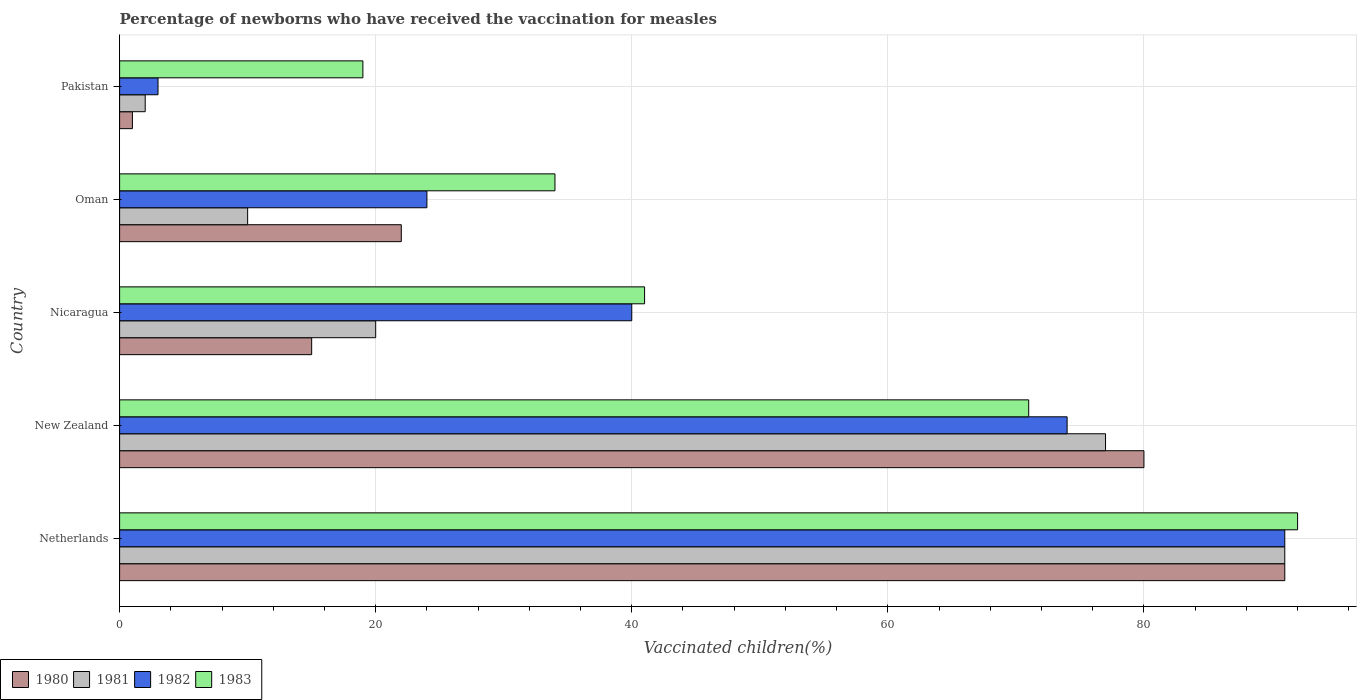How many different coloured bars are there?
Your answer should be very brief. 4. How many groups of bars are there?
Ensure brevity in your answer.  5. Are the number of bars per tick equal to the number of legend labels?
Offer a very short reply. Yes. Are the number of bars on each tick of the Y-axis equal?
Keep it short and to the point. Yes. What is the label of the 2nd group of bars from the top?
Keep it short and to the point. Oman. In how many cases, is the number of bars for a given country not equal to the number of legend labels?
Your answer should be very brief. 0. Across all countries, what is the maximum percentage of vaccinated children in 1981?
Your answer should be compact. 91. In which country was the percentage of vaccinated children in 1980 maximum?
Offer a terse response. Netherlands. In which country was the percentage of vaccinated children in 1980 minimum?
Make the answer very short. Pakistan. What is the total percentage of vaccinated children in 1983 in the graph?
Provide a succinct answer. 257. What is the difference between the percentage of vaccinated children in 1980 in Netherlands and the percentage of vaccinated children in 1983 in New Zealand?
Keep it short and to the point. 20. What is the average percentage of vaccinated children in 1983 per country?
Provide a short and direct response. 51.4. What is the difference between the percentage of vaccinated children in 1980 and percentage of vaccinated children in 1983 in Nicaragua?
Make the answer very short. -26. In how many countries, is the percentage of vaccinated children in 1982 greater than 36 %?
Provide a short and direct response. 3. What is the ratio of the percentage of vaccinated children in 1981 in Nicaragua to that in Oman?
Give a very brief answer. 2. Is the percentage of vaccinated children in 1980 in Oman less than that in Pakistan?
Provide a succinct answer. No. Is the difference between the percentage of vaccinated children in 1980 in Netherlands and Oman greater than the difference between the percentage of vaccinated children in 1983 in Netherlands and Oman?
Your answer should be very brief. Yes. What is the difference between the highest and the second highest percentage of vaccinated children in 1982?
Your answer should be very brief. 17. In how many countries, is the percentage of vaccinated children in 1983 greater than the average percentage of vaccinated children in 1983 taken over all countries?
Your answer should be very brief. 2. Is it the case that in every country, the sum of the percentage of vaccinated children in 1981 and percentage of vaccinated children in 1983 is greater than the sum of percentage of vaccinated children in 1980 and percentage of vaccinated children in 1982?
Your answer should be very brief. No. What does the 1st bar from the top in New Zealand represents?
Keep it short and to the point. 1983. What does the 4th bar from the bottom in New Zealand represents?
Your answer should be very brief. 1983. Is it the case that in every country, the sum of the percentage of vaccinated children in 1981 and percentage of vaccinated children in 1983 is greater than the percentage of vaccinated children in 1982?
Ensure brevity in your answer.  Yes. How many bars are there?
Ensure brevity in your answer.  20. Are all the bars in the graph horizontal?
Ensure brevity in your answer.  Yes. Does the graph contain grids?
Offer a very short reply. Yes. Where does the legend appear in the graph?
Keep it short and to the point. Bottom left. How are the legend labels stacked?
Your answer should be compact. Horizontal. What is the title of the graph?
Provide a succinct answer. Percentage of newborns who have received the vaccination for measles. Does "1981" appear as one of the legend labels in the graph?
Make the answer very short. Yes. What is the label or title of the X-axis?
Your response must be concise. Vaccinated children(%). What is the label or title of the Y-axis?
Provide a short and direct response. Country. What is the Vaccinated children(%) of 1980 in Netherlands?
Make the answer very short. 91. What is the Vaccinated children(%) in 1981 in Netherlands?
Give a very brief answer. 91. What is the Vaccinated children(%) in 1982 in Netherlands?
Provide a succinct answer. 91. What is the Vaccinated children(%) of 1983 in Netherlands?
Your response must be concise. 92. What is the Vaccinated children(%) of 1980 in New Zealand?
Offer a terse response. 80. What is the Vaccinated children(%) in 1982 in New Zealand?
Give a very brief answer. 74. What is the Vaccinated children(%) of 1980 in Nicaragua?
Your answer should be compact. 15. What is the Vaccinated children(%) of 1983 in Nicaragua?
Offer a very short reply. 41. What is the Vaccinated children(%) in 1980 in Oman?
Provide a succinct answer. 22. What is the Vaccinated children(%) in 1981 in Oman?
Ensure brevity in your answer.  10. Across all countries, what is the maximum Vaccinated children(%) of 1980?
Provide a short and direct response. 91. Across all countries, what is the maximum Vaccinated children(%) of 1981?
Your response must be concise. 91. Across all countries, what is the maximum Vaccinated children(%) in 1982?
Your answer should be very brief. 91. Across all countries, what is the maximum Vaccinated children(%) of 1983?
Make the answer very short. 92. Across all countries, what is the minimum Vaccinated children(%) in 1980?
Your response must be concise. 1. Across all countries, what is the minimum Vaccinated children(%) in 1982?
Offer a terse response. 3. What is the total Vaccinated children(%) of 1980 in the graph?
Provide a short and direct response. 209. What is the total Vaccinated children(%) of 1981 in the graph?
Ensure brevity in your answer.  200. What is the total Vaccinated children(%) of 1982 in the graph?
Provide a short and direct response. 232. What is the total Vaccinated children(%) of 1983 in the graph?
Your answer should be compact. 257. What is the difference between the Vaccinated children(%) in 1983 in Netherlands and that in New Zealand?
Keep it short and to the point. 21. What is the difference between the Vaccinated children(%) of 1980 in Netherlands and that in Nicaragua?
Your answer should be compact. 76. What is the difference between the Vaccinated children(%) of 1981 in Netherlands and that in Nicaragua?
Provide a succinct answer. 71. What is the difference between the Vaccinated children(%) of 1983 in Netherlands and that in Nicaragua?
Offer a terse response. 51. What is the difference between the Vaccinated children(%) of 1980 in Netherlands and that in Oman?
Offer a terse response. 69. What is the difference between the Vaccinated children(%) in 1980 in Netherlands and that in Pakistan?
Offer a terse response. 90. What is the difference between the Vaccinated children(%) in 1981 in Netherlands and that in Pakistan?
Offer a very short reply. 89. What is the difference between the Vaccinated children(%) in 1982 in Netherlands and that in Pakistan?
Ensure brevity in your answer.  88. What is the difference between the Vaccinated children(%) of 1983 in Netherlands and that in Pakistan?
Make the answer very short. 73. What is the difference between the Vaccinated children(%) in 1980 in New Zealand and that in Nicaragua?
Offer a very short reply. 65. What is the difference between the Vaccinated children(%) in 1981 in New Zealand and that in Nicaragua?
Ensure brevity in your answer.  57. What is the difference between the Vaccinated children(%) in 1983 in New Zealand and that in Nicaragua?
Your answer should be very brief. 30. What is the difference between the Vaccinated children(%) of 1980 in New Zealand and that in Pakistan?
Your response must be concise. 79. What is the difference between the Vaccinated children(%) of 1981 in New Zealand and that in Pakistan?
Ensure brevity in your answer.  75. What is the difference between the Vaccinated children(%) in 1980 in Nicaragua and that in Oman?
Make the answer very short. -7. What is the difference between the Vaccinated children(%) in 1981 in Nicaragua and that in Oman?
Give a very brief answer. 10. What is the difference between the Vaccinated children(%) in 1982 in Nicaragua and that in Oman?
Provide a short and direct response. 16. What is the difference between the Vaccinated children(%) of 1983 in Nicaragua and that in Oman?
Your answer should be compact. 7. What is the difference between the Vaccinated children(%) of 1980 in Oman and that in Pakistan?
Keep it short and to the point. 21. What is the difference between the Vaccinated children(%) in 1982 in Oman and that in Pakistan?
Your response must be concise. 21. What is the difference between the Vaccinated children(%) in 1980 in Netherlands and the Vaccinated children(%) in 1981 in New Zealand?
Offer a terse response. 14. What is the difference between the Vaccinated children(%) in 1980 in Netherlands and the Vaccinated children(%) in 1982 in New Zealand?
Offer a terse response. 17. What is the difference between the Vaccinated children(%) of 1981 in Netherlands and the Vaccinated children(%) of 1983 in New Zealand?
Make the answer very short. 20. What is the difference between the Vaccinated children(%) in 1982 in Netherlands and the Vaccinated children(%) in 1983 in New Zealand?
Offer a terse response. 20. What is the difference between the Vaccinated children(%) of 1980 in Netherlands and the Vaccinated children(%) of 1981 in Nicaragua?
Provide a succinct answer. 71. What is the difference between the Vaccinated children(%) in 1981 in Netherlands and the Vaccinated children(%) in 1982 in Nicaragua?
Keep it short and to the point. 51. What is the difference between the Vaccinated children(%) of 1981 in Netherlands and the Vaccinated children(%) of 1983 in Nicaragua?
Provide a short and direct response. 50. What is the difference between the Vaccinated children(%) in 1982 in Netherlands and the Vaccinated children(%) in 1983 in Nicaragua?
Your response must be concise. 50. What is the difference between the Vaccinated children(%) of 1980 in Netherlands and the Vaccinated children(%) of 1982 in Oman?
Ensure brevity in your answer.  67. What is the difference between the Vaccinated children(%) of 1980 in Netherlands and the Vaccinated children(%) of 1983 in Oman?
Offer a terse response. 57. What is the difference between the Vaccinated children(%) of 1981 in Netherlands and the Vaccinated children(%) of 1983 in Oman?
Make the answer very short. 57. What is the difference between the Vaccinated children(%) of 1980 in Netherlands and the Vaccinated children(%) of 1981 in Pakistan?
Your answer should be very brief. 89. What is the difference between the Vaccinated children(%) in 1980 in Netherlands and the Vaccinated children(%) in 1983 in Pakistan?
Keep it short and to the point. 72. What is the difference between the Vaccinated children(%) of 1980 in New Zealand and the Vaccinated children(%) of 1983 in Nicaragua?
Ensure brevity in your answer.  39. What is the difference between the Vaccinated children(%) in 1982 in New Zealand and the Vaccinated children(%) in 1983 in Oman?
Give a very brief answer. 40. What is the difference between the Vaccinated children(%) in 1980 in New Zealand and the Vaccinated children(%) in 1982 in Pakistan?
Ensure brevity in your answer.  77. What is the difference between the Vaccinated children(%) in 1980 in New Zealand and the Vaccinated children(%) in 1983 in Pakistan?
Your answer should be very brief. 61. What is the difference between the Vaccinated children(%) in 1981 in New Zealand and the Vaccinated children(%) in 1982 in Pakistan?
Your response must be concise. 74. What is the difference between the Vaccinated children(%) of 1980 in Nicaragua and the Vaccinated children(%) of 1981 in Oman?
Provide a succinct answer. 5. What is the difference between the Vaccinated children(%) of 1980 in Nicaragua and the Vaccinated children(%) of 1982 in Oman?
Offer a terse response. -9. What is the difference between the Vaccinated children(%) in 1980 in Nicaragua and the Vaccinated children(%) in 1983 in Oman?
Your answer should be compact. -19. What is the difference between the Vaccinated children(%) of 1981 in Nicaragua and the Vaccinated children(%) of 1983 in Oman?
Give a very brief answer. -14. What is the difference between the Vaccinated children(%) in 1980 in Nicaragua and the Vaccinated children(%) in 1981 in Pakistan?
Provide a succinct answer. 13. What is the difference between the Vaccinated children(%) of 1981 in Nicaragua and the Vaccinated children(%) of 1982 in Pakistan?
Offer a very short reply. 17. What is the difference between the Vaccinated children(%) in 1980 in Oman and the Vaccinated children(%) in 1982 in Pakistan?
Keep it short and to the point. 19. What is the difference between the Vaccinated children(%) of 1981 in Oman and the Vaccinated children(%) of 1982 in Pakistan?
Keep it short and to the point. 7. What is the difference between the Vaccinated children(%) of 1982 in Oman and the Vaccinated children(%) of 1983 in Pakistan?
Offer a very short reply. 5. What is the average Vaccinated children(%) of 1980 per country?
Keep it short and to the point. 41.8. What is the average Vaccinated children(%) in 1981 per country?
Your answer should be compact. 40. What is the average Vaccinated children(%) of 1982 per country?
Give a very brief answer. 46.4. What is the average Vaccinated children(%) of 1983 per country?
Give a very brief answer. 51.4. What is the difference between the Vaccinated children(%) of 1980 and Vaccinated children(%) of 1982 in Netherlands?
Provide a succinct answer. 0. What is the difference between the Vaccinated children(%) in 1980 and Vaccinated children(%) in 1983 in Netherlands?
Offer a terse response. -1. What is the difference between the Vaccinated children(%) in 1980 and Vaccinated children(%) in 1981 in New Zealand?
Your response must be concise. 3. What is the difference between the Vaccinated children(%) of 1980 and Vaccinated children(%) of 1982 in New Zealand?
Keep it short and to the point. 6. What is the difference between the Vaccinated children(%) in 1981 and Vaccinated children(%) in 1982 in New Zealand?
Ensure brevity in your answer.  3. What is the difference between the Vaccinated children(%) in 1982 and Vaccinated children(%) in 1983 in New Zealand?
Your response must be concise. 3. What is the difference between the Vaccinated children(%) in 1980 and Vaccinated children(%) in 1981 in Nicaragua?
Your answer should be very brief. -5. What is the difference between the Vaccinated children(%) in 1980 and Vaccinated children(%) in 1982 in Nicaragua?
Make the answer very short. -25. What is the difference between the Vaccinated children(%) of 1981 and Vaccinated children(%) of 1982 in Nicaragua?
Offer a terse response. -20. What is the difference between the Vaccinated children(%) of 1981 and Vaccinated children(%) of 1983 in Nicaragua?
Keep it short and to the point. -21. What is the difference between the Vaccinated children(%) in 1980 and Vaccinated children(%) in 1981 in Oman?
Ensure brevity in your answer.  12. What is the difference between the Vaccinated children(%) of 1980 and Vaccinated children(%) of 1982 in Oman?
Give a very brief answer. -2. What is the difference between the Vaccinated children(%) in 1980 and Vaccinated children(%) in 1983 in Oman?
Make the answer very short. -12. What is the difference between the Vaccinated children(%) in 1981 and Vaccinated children(%) in 1983 in Oman?
Your answer should be very brief. -24. What is the difference between the Vaccinated children(%) in 1980 and Vaccinated children(%) in 1981 in Pakistan?
Your response must be concise. -1. What is the difference between the Vaccinated children(%) of 1981 and Vaccinated children(%) of 1983 in Pakistan?
Give a very brief answer. -17. What is the ratio of the Vaccinated children(%) of 1980 in Netherlands to that in New Zealand?
Give a very brief answer. 1.14. What is the ratio of the Vaccinated children(%) in 1981 in Netherlands to that in New Zealand?
Provide a short and direct response. 1.18. What is the ratio of the Vaccinated children(%) in 1982 in Netherlands to that in New Zealand?
Keep it short and to the point. 1.23. What is the ratio of the Vaccinated children(%) of 1983 in Netherlands to that in New Zealand?
Your answer should be compact. 1.3. What is the ratio of the Vaccinated children(%) of 1980 in Netherlands to that in Nicaragua?
Your answer should be very brief. 6.07. What is the ratio of the Vaccinated children(%) of 1981 in Netherlands to that in Nicaragua?
Offer a very short reply. 4.55. What is the ratio of the Vaccinated children(%) of 1982 in Netherlands to that in Nicaragua?
Provide a short and direct response. 2.27. What is the ratio of the Vaccinated children(%) of 1983 in Netherlands to that in Nicaragua?
Ensure brevity in your answer.  2.24. What is the ratio of the Vaccinated children(%) in 1980 in Netherlands to that in Oman?
Your response must be concise. 4.14. What is the ratio of the Vaccinated children(%) of 1981 in Netherlands to that in Oman?
Your response must be concise. 9.1. What is the ratio of the Vaccinated children(%) in 1982 in Netherlands to that in Oman?
Your response must be concise. 3.79. What is the ratio of the Vaccinated children(%) of 1983 in Netherlands to that in Oman?
Give a very brief answer. 2.71. What is the ratio of the Vaccinated children(%) of 1980 in Netherlands to that in Pakistan?
Ensure brevity in your answer.  91. What is the ratio of the Vaccinated children(%) of 1981 in Netherlands to that in Pakistan?
Offer a terse response. 45.5. What is the ratio of the Vaccinated children(%) of 1982 in Netherlands to that in Pakistan?
Give a very brief answer. 30.33. What is the ratio of the Vaccinated children(%) in 1983 in Netherlands to that in Pakistan?
Keep it short and to the point. 4.84. What is the ratio of the Vaccinated children(%) in 1980 in New Zealand to that in Nicaragua?
Ensure brevity in your answer.  5.33. What is the ratio of the Vaccinated children(%) in 1981 in New Zealand to that in Nicaragua?
Offer a very short reply. 3.85. What is the ratio of the Vaccinated children(%) in 1982 in New Zealand to that in Nicaragua?
Provide a short and direct response. 1.85. What is the ratio of the Vaccinated children(%) of 1983 in New Zealand to that in Nicaragua?
Provide a short and direct response. 1.73. What is the ratio of the Vaccinated children(%) of 1980 in New Zealand to that in Oman?
Offer a very short reply. 3.64. What is the ratio of the Vaccinated children(%) in 1981 in New Zealand to that in Oman?
Provide a succinct answer. 7.7. What is the ratio of the Vaccinated children(%) in 1982 in New Zealand to that in Oman?
Your answer should be compact. 3.08. What is the ratio of the Vaccinated children(%) in 1983 in New Zealand to that in Oman?
Make the answer very short. 2.09. What is the ratio of the Vaccinated children(%) in 1980 in New Zealand to that in Pakistan?
Offer a terse response. 80. What is the ratio of the Vaccinated children(%) in 1981 in New Zealand to that in Pakistan?
Your answer should be compact. 38.5. What is the ratio of the Vaccinated children(%) of 1982 in New Zealand to that in Pakistan?
Offer a very short reply. 24.67. What is the ratio of the Vaccinated children(%) of 1983 in New Zealand to that in Pakistan?
Provide a short and direct response. 3.74. What is the ratio of the Vaccinated children(%) in 1980 in Nicaragua to that in Oman?
Your response must be concise. 0.68. What is the ratio of the Vaccinated children(%) in 1983 in Nicaragua to that in Oman?
Your answer should be compact. 1.21. What is the ratio of the Vaccinated children(%) in 1980 in Nicaragua to that in Pakistan?
Your response must be concise. 15. What is the ratio of the Vaccinated children(%) in 1982 in Nicaragua to that in Pakistan?
Provide a succinct answer. 13.33. What is the ratio of the Vaccinated children(%) of 1983 in Nicaragua to that in Pakistan?
Your response must be concise. 2.16. What is the ratio of the Vaccinated children(%) in 1980 in Oman to that in Pakistan?
Your answer should be compact. 22. What is the ratio of the Vaccinated children(%) of 1982 in Oman to that in Pakistan?
Keep it short and to the point. 8. What is the ratio of the Vaccinated children(%) of 1983 in Oman to that in Pakistan?
Keep it short and to the point. 1.79. What is the difference between the highest and the second highest Vaccinated children(%) in 1980?
Ensure brevity in your answer.  11. What is the difference between the highest and the lowest Vaccinated children(%) in 1980?
Provide a succinct answer. 90. What is the difference between the highest and the lowest Vaccinated children(%) of 1981?
Offer a very short reply. 89. What is the difference between the highest and the lowest Vaccinated children(%) of 1983?
Your answer should be compact. 73. 